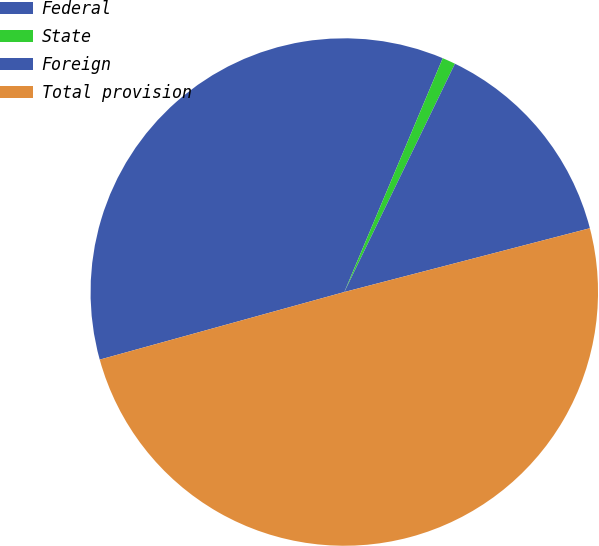Convert chart to OTSL. <chart><loc_0><loc_0><loc_500><loc_500><pie_chart><fcel>Federal<fcel>State<fcel>Foreign<fcel>Total provision<nl><fcel>35.63%<fcel>0.84%<fcel>13.77%<fcel>49.75%<nl></chart> 